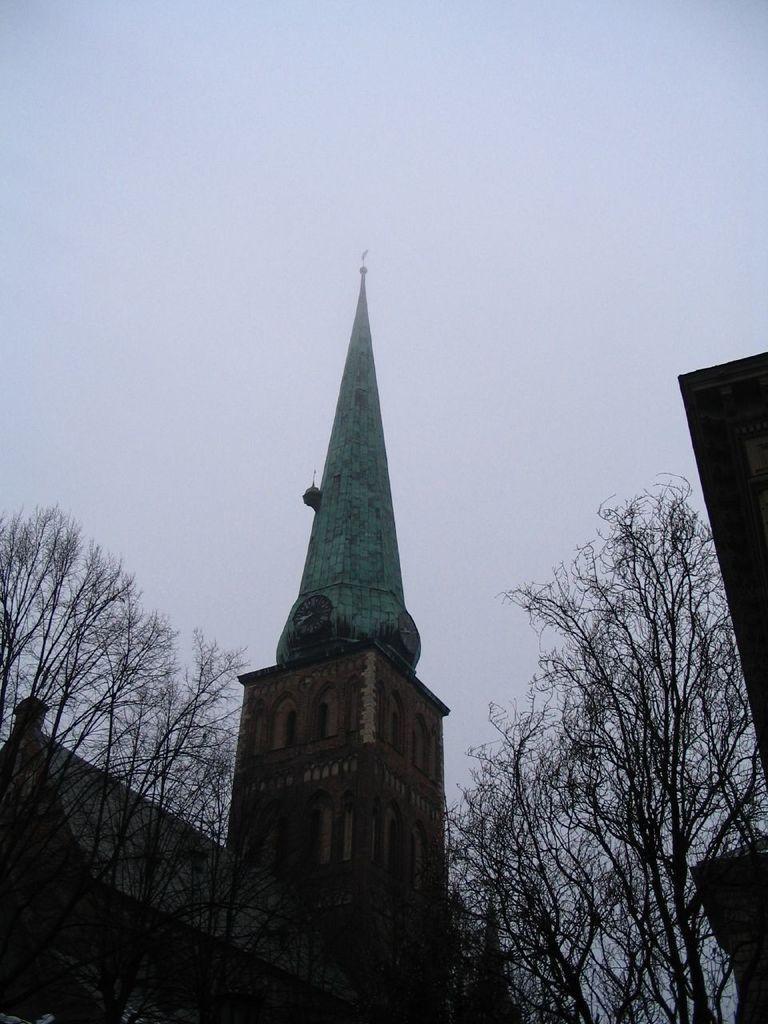Describe this image in one or two sentences. In this image we can see a building with windows. We can also see a group of trees and the sky which looks cloudy. 